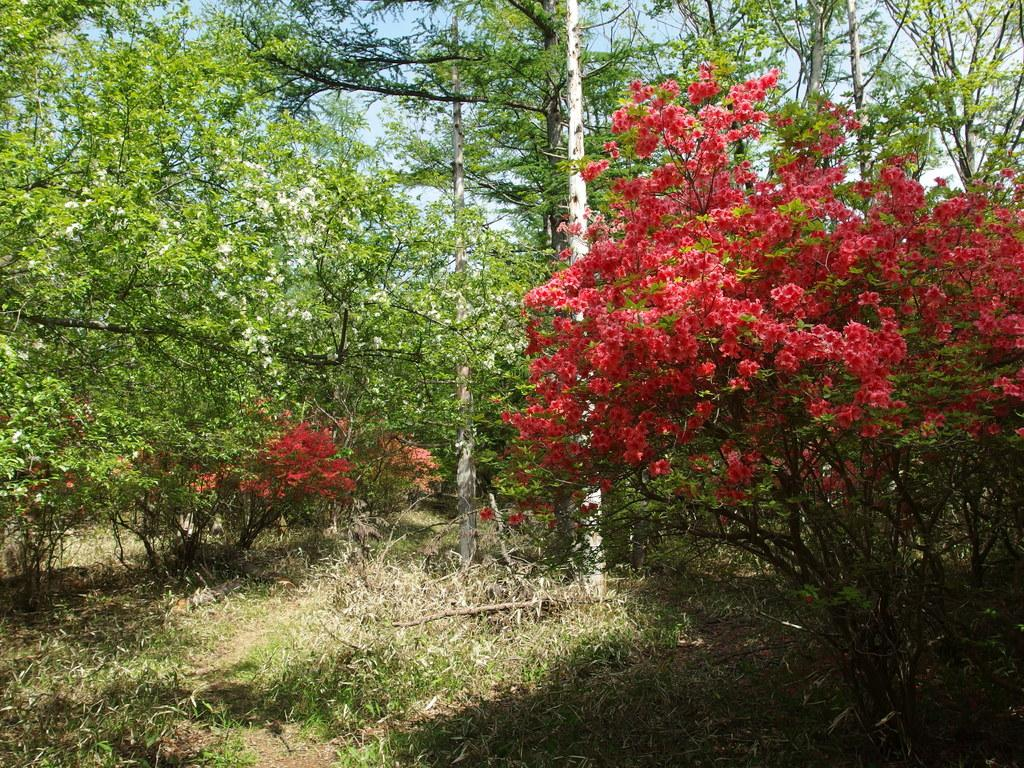What type of vegetation is present on the ground in the front of the image? There is grass on the ground in the front of the image. What can be seen in the background of the image? There are trees in the background of the image. Where are the flowers located in the image? The flowers are on the right side of the image. Can you tell me how many berries are growing on the trees in the image? There are no berries mentioned or visible in the image; it features grass, trees, and flowers. Is there a lake visible in the image? There is no lake present in the image. 